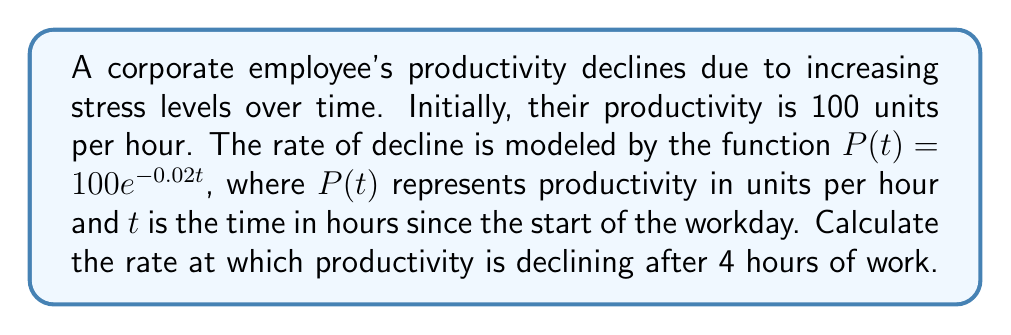Could you help me with this problem? To find the rate at which productivity is declining, we need to calculate the derivative of the productivity function $P(t)$ and evaluate it at $t = 4$.

Step 1: Express the productivity function.
$$P(t) = 100e^{-0.02t}$$

Step 2: Calculate the derivative of $P(t)$ using the chain rule.
$$\frac{dP}{dt} = 100 \cdot (-0.02) \cdot e^{-0.02t} = -2e^{-0.02t}$$

Step 3: Evaluate the derivative at $t = 4$.
$$\frac{dP}{dt}\bigg|_{t=4} = -2e^{-0.02(4)} = -2e^{-0.08}$$

Step 4: Calculate the final value.
$$\frac{dP}{dt}\bigg|_{t=4} = -2 \cdot 0.9231 = -1.8462$$

The negative sign indicates that productivity is decreasing. The rate of decline after 4 hours is approximately 1.8462 units per hour per hour.
Answer: $-1.8462$ units/hour² 